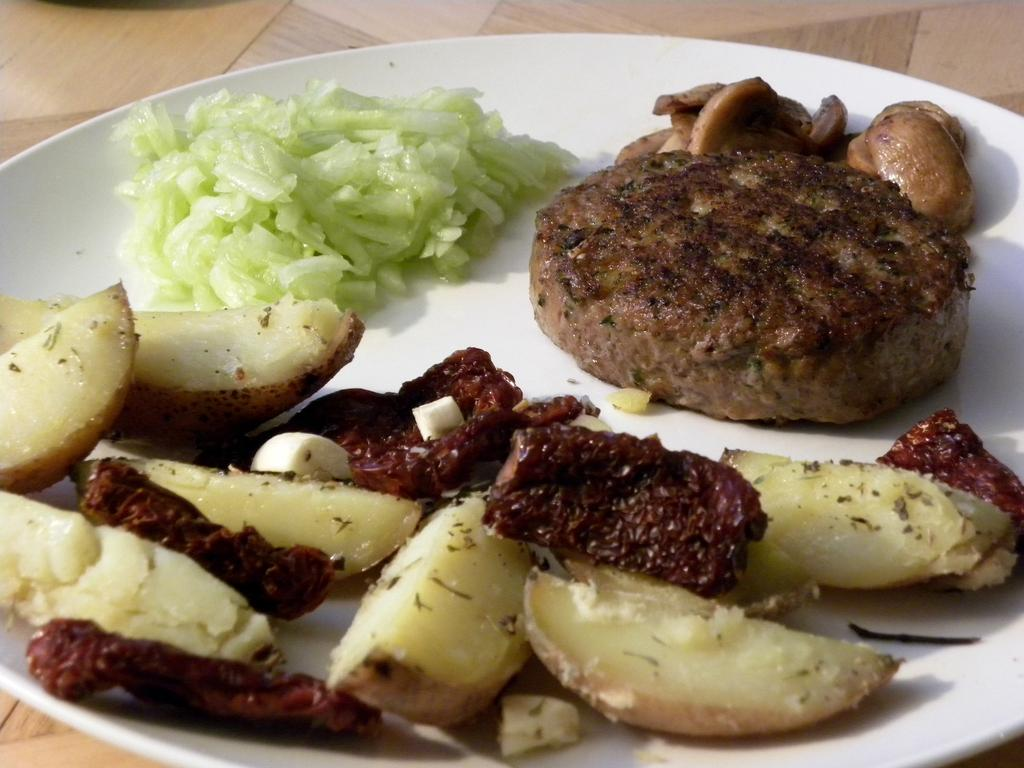What piece of furniture is present in the image? There is a table in the image. What is placed on the table? There is a plate on the table. What type of food is on the plate? There is a sweet potato on the plate. Are there any other food items on the plate? Yes, there are other food items on the plate. What type of beef is present in the image? There is no beef present in the image. The image features a table, a plate, a sweet potato, and other food items. 